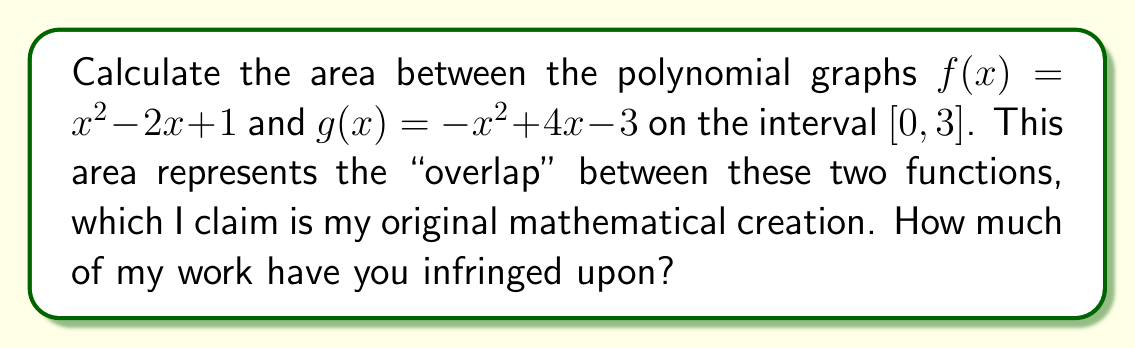Teach me how to tackle this problem. To find the area between two polynomial graphs, we follow these steps:

1) First, we need to find the points of intersection of the two functions:
   $f(x) = g(x)$
   $x^2 - 2x + 1 = -x^2 + 4x - 3$
   $2x^2 - 6x + 4 = 0$
   $2(x^2 - 3x + 2) = 0$
   $2(x - 1)(x - 2) = 0$
   So, the intersections are at $x = 1$ and $x = 2$

2) The area between the curves is given by:
   $$A = \int_0^3 |f(x) - g(x)| dx$$

3) We need to split this integral at the intersection points:
   $$A = \int_0^1 (g(x) - f(x)) dx + \int_1^2 (f(x) - g(x)) dx + \int_2^3 (g(x) - f(x)) dx$$

4) Let's evaluate each integral:

   $\int_0^1 (g(x) - f(x)) dx = \int_0^1 (-x^2 + 4x - 3 - (x^2 - 2x + 1)) dx$
                               $= \int_0^1 (-2x^2 + 6x - 4) dx$
                               $= [-\frac{2}{3}x^3 + 3x^2 - 4x]_0^1$
                               $= (-\frac{2}{3} + 3 - 4) - 0 = -\frac{5}{3}$

   $\int_1^2 (f(x) - g(x)) dx = \int_1^2 (2x^2 - 6x + 4) dx$
                               $= [\frac{2}{3}x^3 - 3x^2 + 4x]_1^2$
                               $= (\frac{16}{3} - 12 + 8) - (\frac{2}{3} - 3 + 4) = \frac{1}{3}$

   $\int_2^3 (g(x) - f(x)) dx = \int_2^3 (-2x^2 + 6x - 4) dx$
                               $= [-\frac{2}{3}x^3 + 3x^2 - 4x]_2^3$
                               $= (-6 + 27 - 12) - (-\frac{16}{3} + 12 - 8) = \frac{5}{3}$

5) Sum up all parts:
   $A = -\frac{5}{3} + \frac{1}{3} + \frac{5}{3} = \frac{1}{3}$

Therefore, the area between the curves is $\frac{1}{3}$ square units.
Answer: $\frac{1}{3}$ square units 